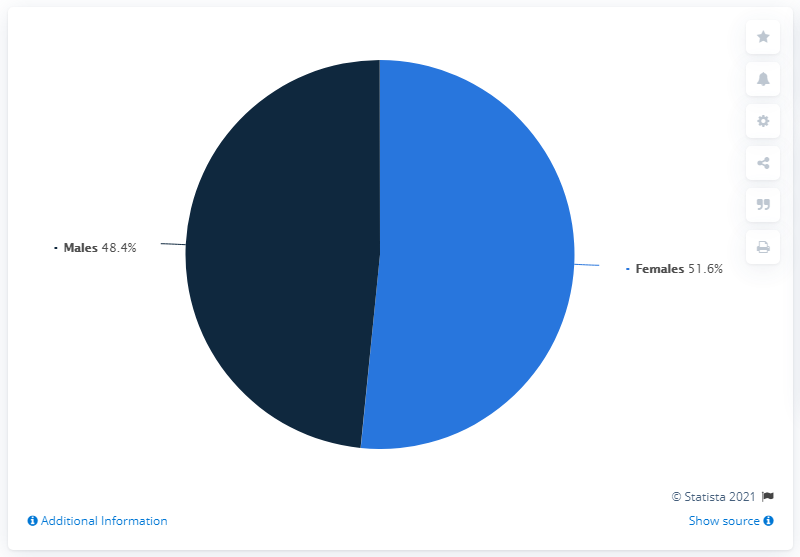Mention a couple of crucial points in this snapshot. What is the difference between the two colors? 3.2.." is a question asking for a comparison between two colors. The color that occupies more space in the pie chart is light blue. 